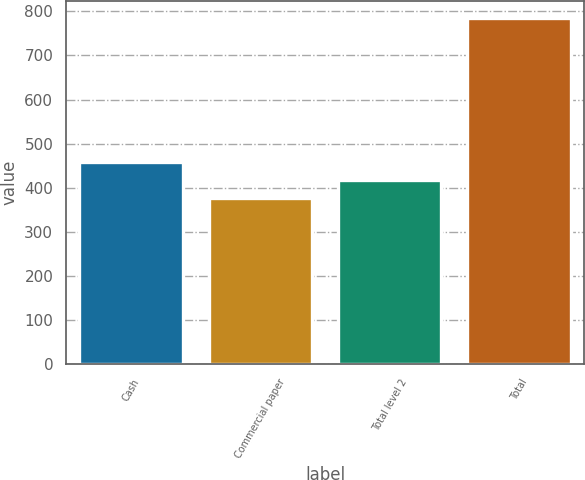<chart> <loc_0><loc_0><loc_500><loc_500><bar_chart><fcel>Cash<fcel>Commercial paper<fcel>Total level 2<fcel>Total<nl><fcel>457.8<fcel>376<fcel>416.9<fcel>785<nl></chart> 